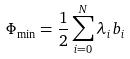Convert formula to latex. <formula><loc_0><loc_0><loc_500><loc_500>\Phi _ { \min } = \frac { 1 } { 2 } \sum _ { i = 0 } ^ { N } \lambda _ { i } b _ { i }</formula> 